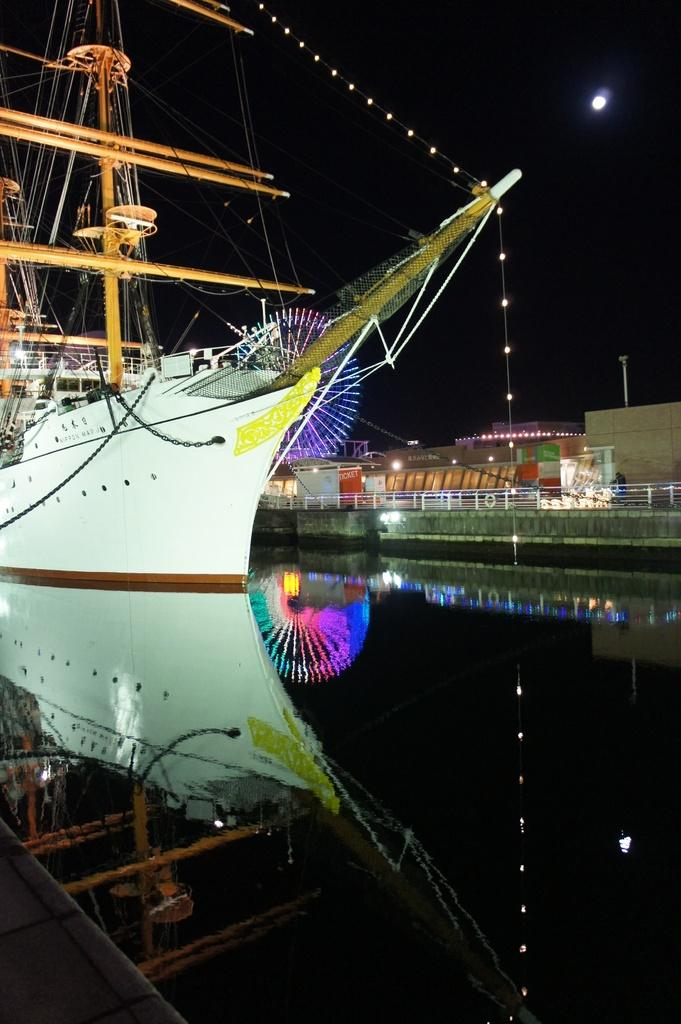What is the main subject of the image? There is a ship in the image. Where is the ship located? The ship is on the water. What can be seen in the background of the image? There are buildings and lights visible in the background of the image. What part of the natural environment is visible in the image? The sky is visible in the image. What type of curtain can be seen hanging from the ship's windows in the image? There are no curtains visible on the ship's windows in the image. 